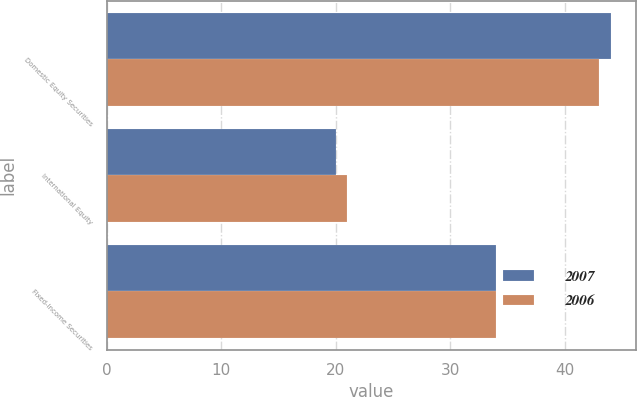Convert chart. <chart><loc_0><loc_0><loc_500><loc_500><stacked_bar_chart><ecel><fcel>Domestic Equity Securities<fcel>International Equity<fcel>Fixed-Income Securities<nl><fcel>2007<fcel>44<fcel>20<fcel>34<nl><fcel>2006<fcel>43<fcel>21<fcel>34<nl></chart> 